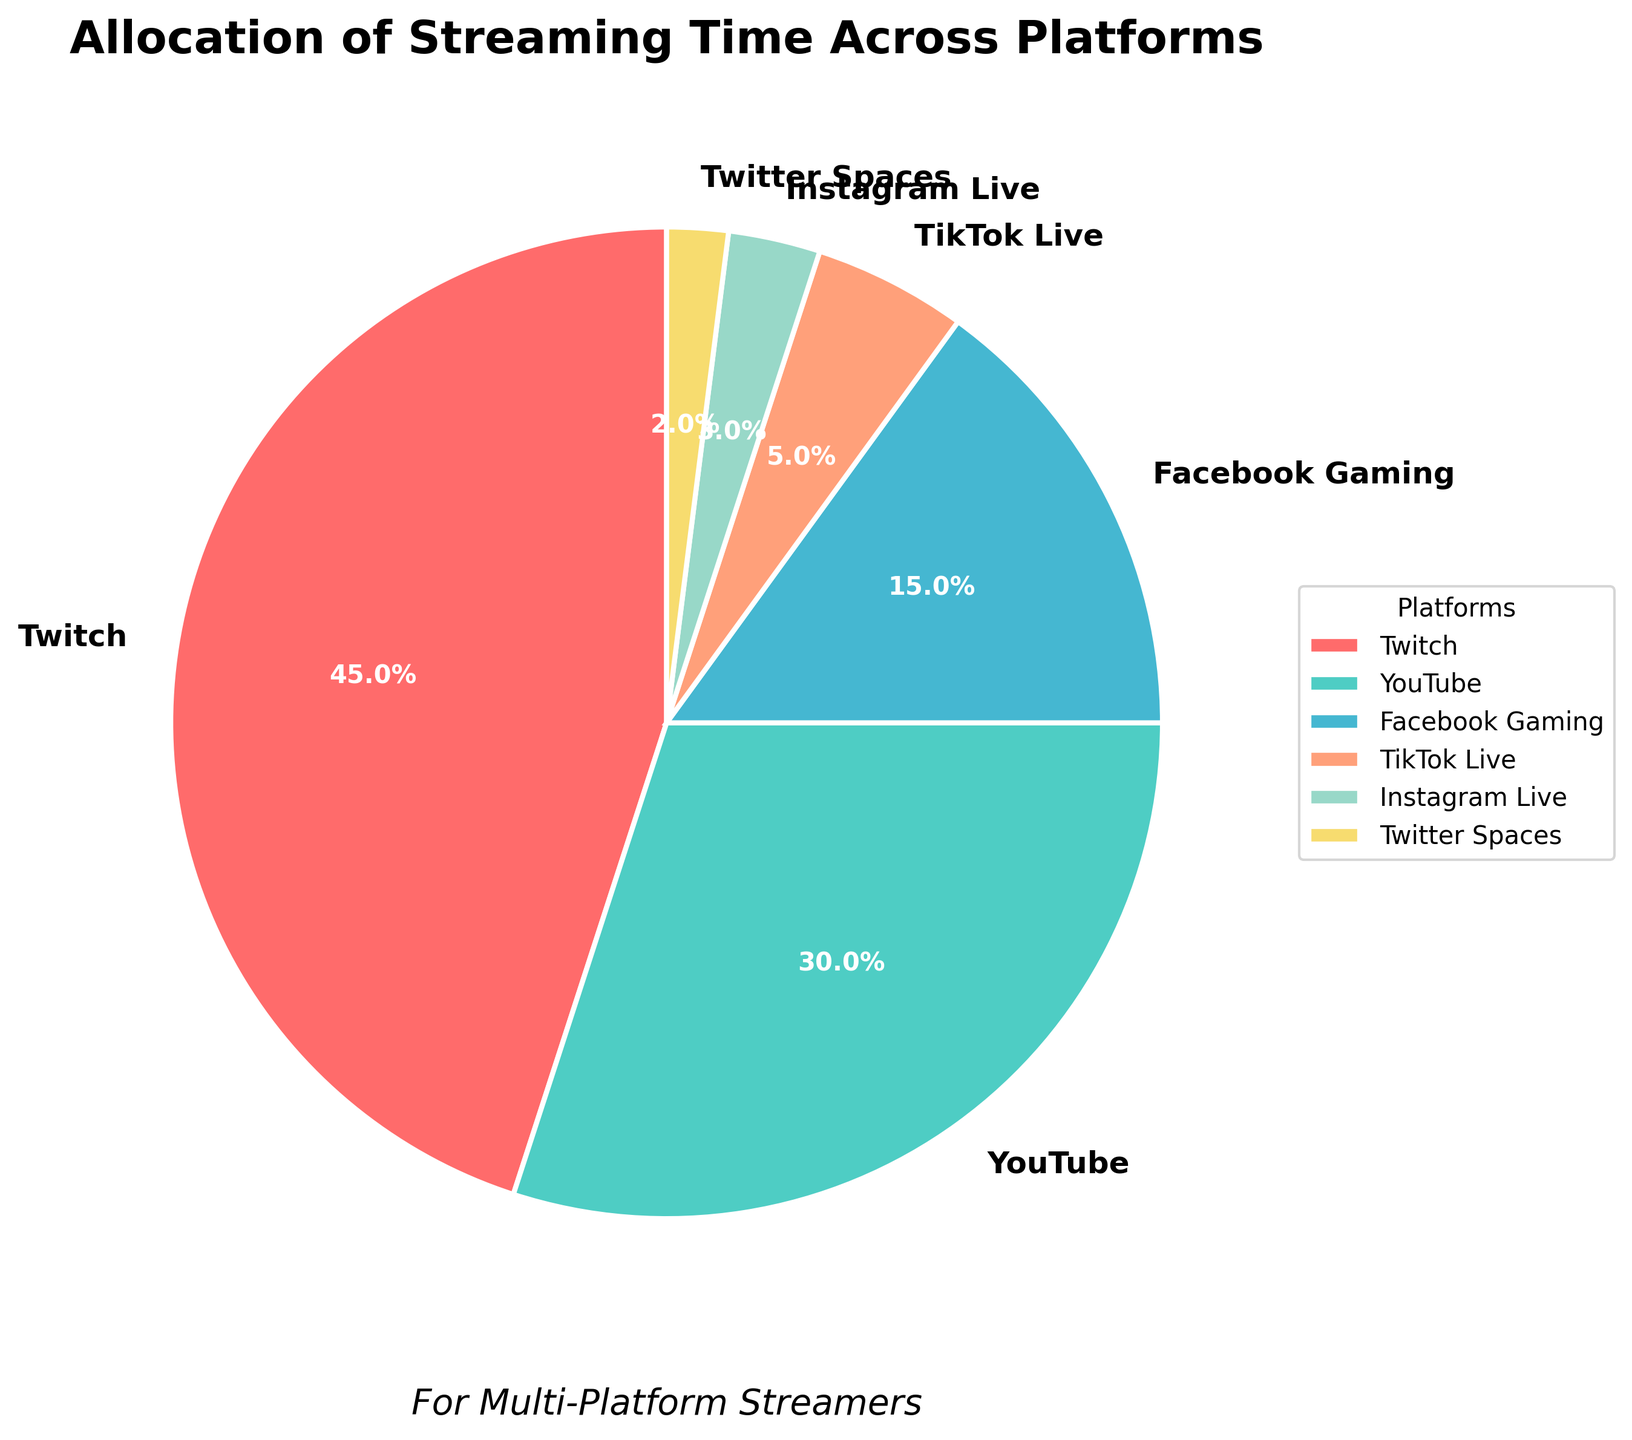What is the largest allocation of streaming time among the platforms? The slice representing the allocation of streaming time for Twitch is the largest with a percentage label of 45%.
Answer: Twitch Which platform has the smallest allocation of streaming time? The slice representing the allocation for Twitter Spaces is the smallest with a percentage label of 2%.
Answer: Twitter Spaces What is the total percentage of streaming time allocated to YouTube and Facebook Gaming combined? YouTube has a 30% allocation, and Facebook Gaming has a 15% allocation. Summing these percentages gives 30% + 15% = 45%.
Answer: 45% By how much does Twitch's allocation exceed YouTube's? Twitch has a 45% allocation, and YouTube has a 30% allocation. The difference is 45% - 30% = 15%.
Answer: 15% Which color represents Instagram Live in the pie chart? The slice for Instagram Live is represented with a visually identifiable color. Based on the custom colors used, Instagram Live is shown in a peach color.
Answer: Peach What is the combined percentage of streaming time allocated to TikTok Live and Twitter Spaces? TikTok Live has a 5% allocation, and Twitter Spaces has a 2% allocation. Summing these percentages gives 5% + 2% = 7%.
Answer: 7% Are YouTube and Facebook Gaming combined greater than Twitch? By how much? The combined allocation for YouTube and Facebook Gaming is 30% + 15% = 45%. Twitch also has 45% allocation. Therefore, they are equal, and the difference is 0%.
Answer: 0% Order the platforms from highest to lowest allocation of streaming time. Referring to the percentage labels on the pie chart, the platforms can be ordered as follows: Twitch (45%), YouTube (30%), Facebook Gaming (15%), TikTok Live (5%), Instagram Live (3%), Twitter Spaces (2%).
Answer: Twitch, YouTube, Facebook Gaming, TikTok Live, Instagram Live, Twitter Spaces 